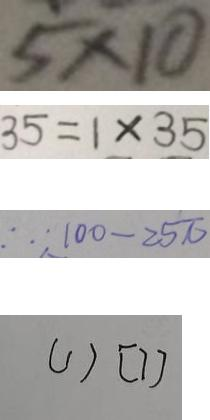<formula> <loc_0><loc_0><loc_500><loc_500>5 \times 1 0 
 3 5 = 1 \times 3 5 
 \therefore 1 0 0 - 2 5 \pi 
 ( 1 ) [ 7 ]</formula> 